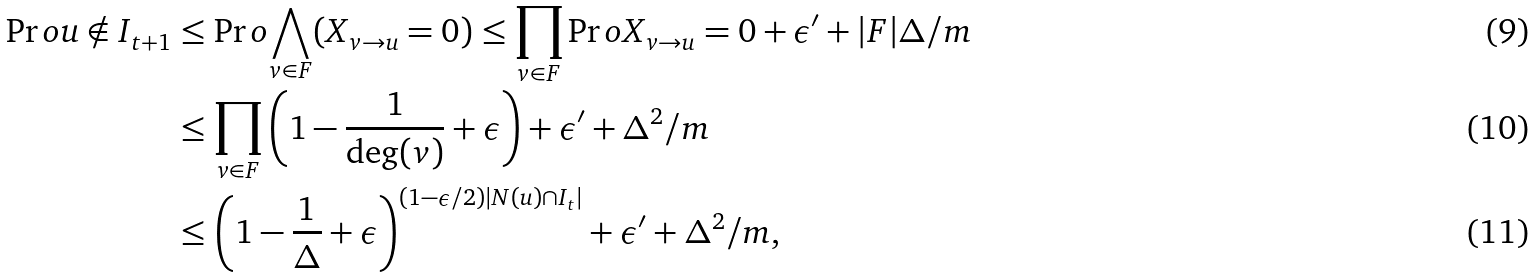<formula> <loc_0><loc_0><loc_500><loc_500>\Pr o { u \notin I _ { t + 1 } } & \leq \Pr o { \bigwedge _ { v \in F } ( X _ { v \rightarrow u } = 0 ) } \leq \prod _ { v \in F } \Pr o { X _ { v \rightarrow u } = 0 } + \epsilon ^ { \prime } + | F | \Delta / m \\ & \leq \prod _ { v \in F } \left ( 1 - \frac { 1 } { \deg ( v ) } + \epsilon \right ) + \epsilon ^ { \prime } + \Delta ^ { 2 } / m \\ & \leq \left ( 1 - \frac { 1 } { \Delta } + \epsilon \right ) ^ { ( 1 - \epsilon / 2 ) | N ( u ) \cap I _ { t } | } + \epsilon ^ { \prime } + \Delta ^ { 2 } / m ,</formula> 